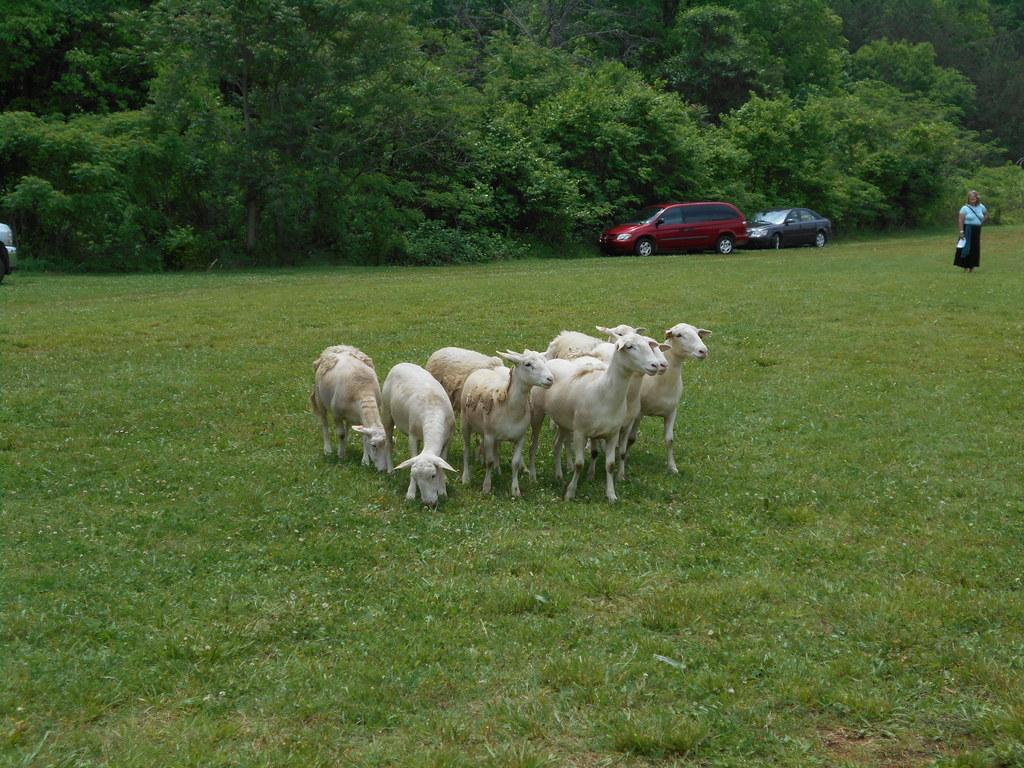What type of animals are in the image? There are white color goats in the image. Where are the goats located in the image? The goats are standing on the ground. What can be seen in the background of the image? There are vehicles, a person, trees, grass, and other objects present in the background of the image. What type of meat is being cooked in the soup in the image? There is no soup or meat present in the image; it features white color goats standing on the ground with a background that includes vehicles, a person, trees, grass, and other objects. 